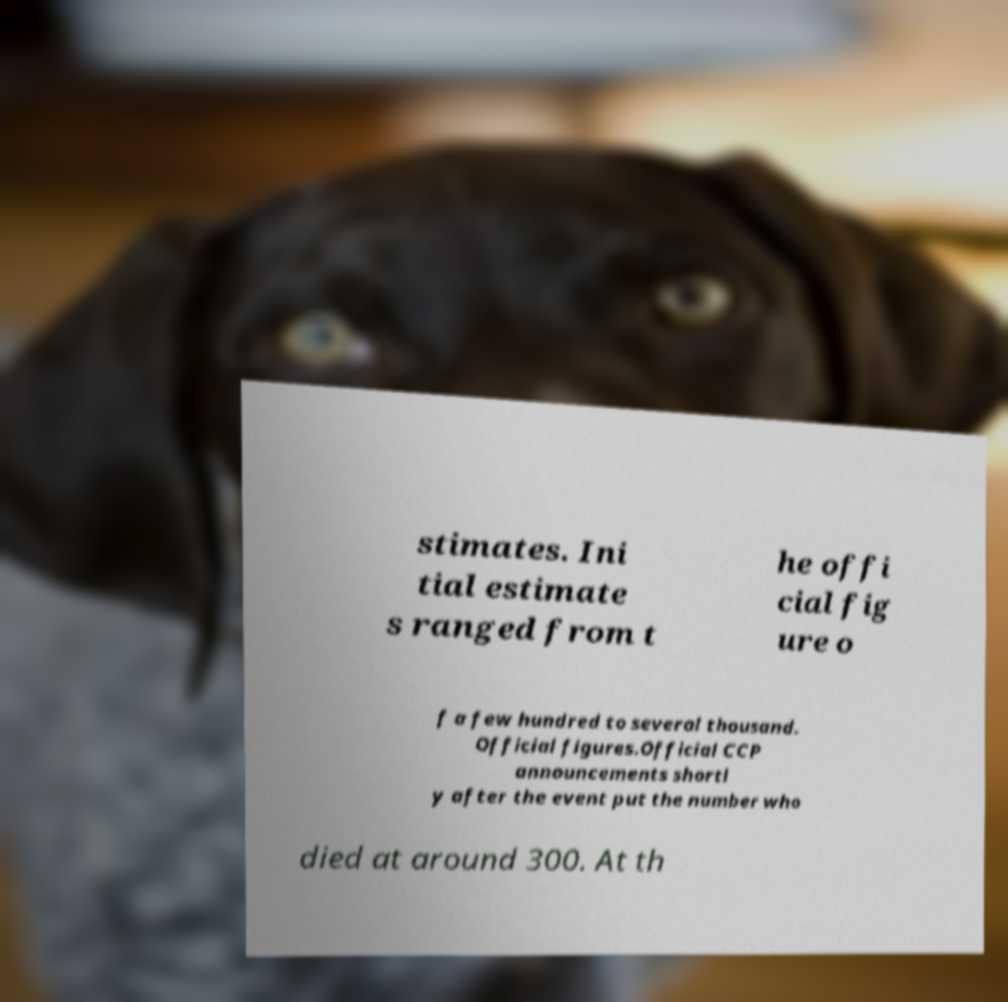Could you assist in decoding the text presented in this image and type it out clearly? stimates. Ini tial estimate s ranged from t he offi cial fig ure o f a few hundred to several thousand. Official figures.Official CCP announcements shortl y after the event put the number who died at around 300. At th 